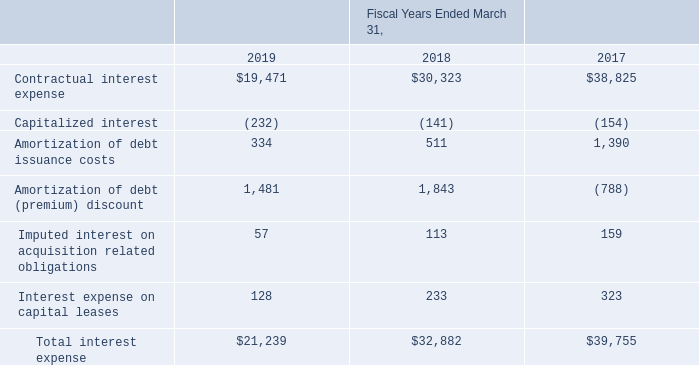Note 3: Debt
The line item “Interest expense” on the Consolidated Statements of Operations for the fiscal years 2019, 2018 and 2017, respectively, is as follows (amounts in thousands):
What was the Contractual interest expense in 2017?
Answer scale should be: thousand. 38,825. What was the Capitalized interest in 2019?
Answer scale should be: thousand. (232). What was the Interest expense on capital leases in 2018?
Answer scale should be: thousand. 233. What was the change in the Amortization of debt issuance costs between 2017 and 2018?
Answer scale should be: thousand. 511-1,390
Answer: -879. How many years did Interest expense on capital leases exceed $200 thousand? 2018##2017
Answer: 2. What was the percentage change in the total interest expense between 2018 and 2019?
Answer scale should be: percent. (21,239-32,882)/32,882
Answer: -35.41. 